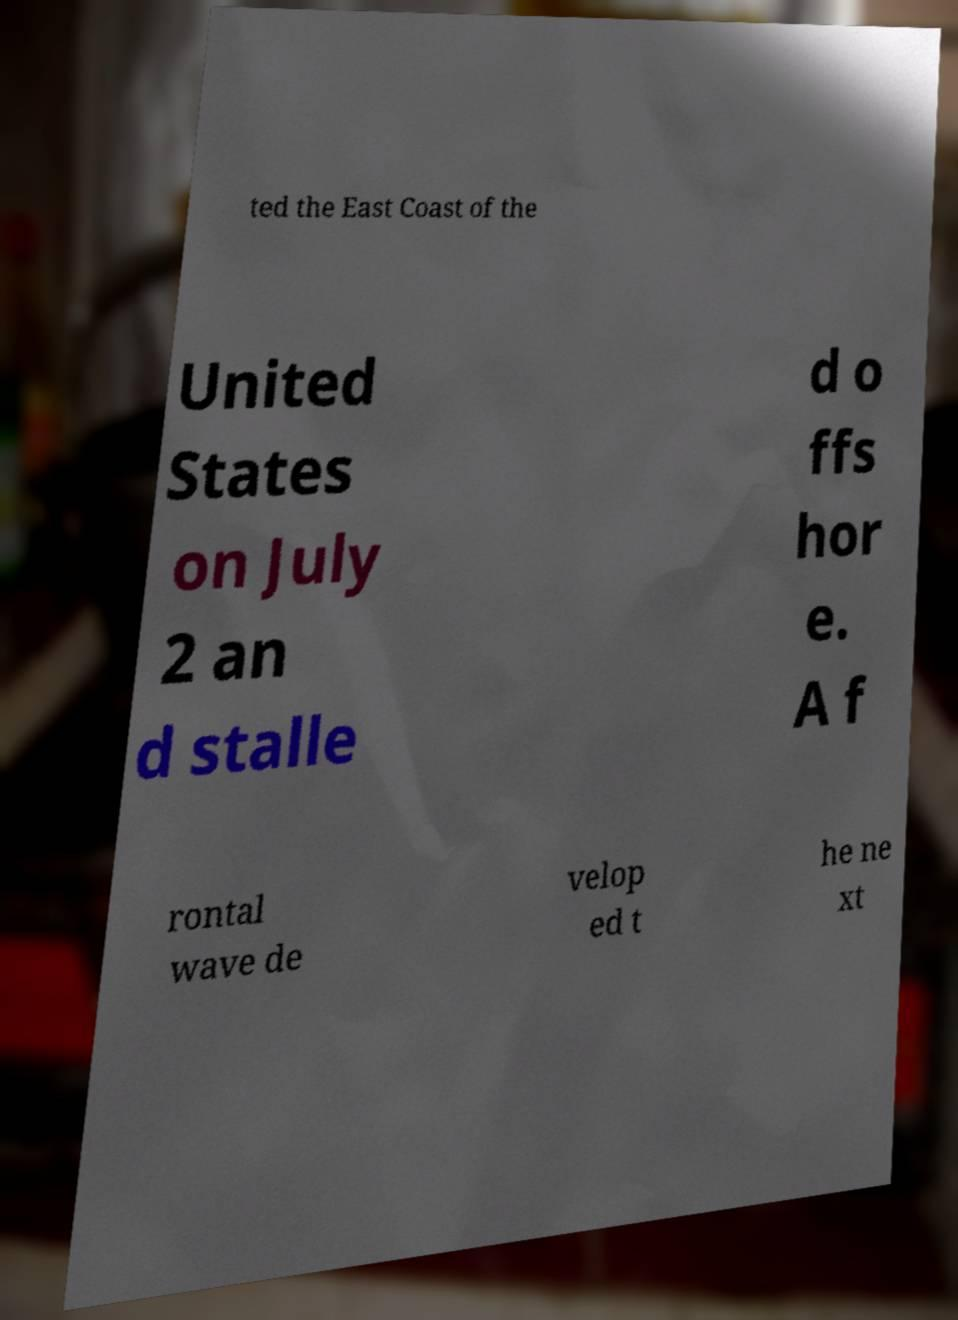Could you extract and type out the text from this image? ted the East Coast of the United States on July 2 an d stalle d o ffs hor e. A f rontal wave de velop ed t he ne xt 